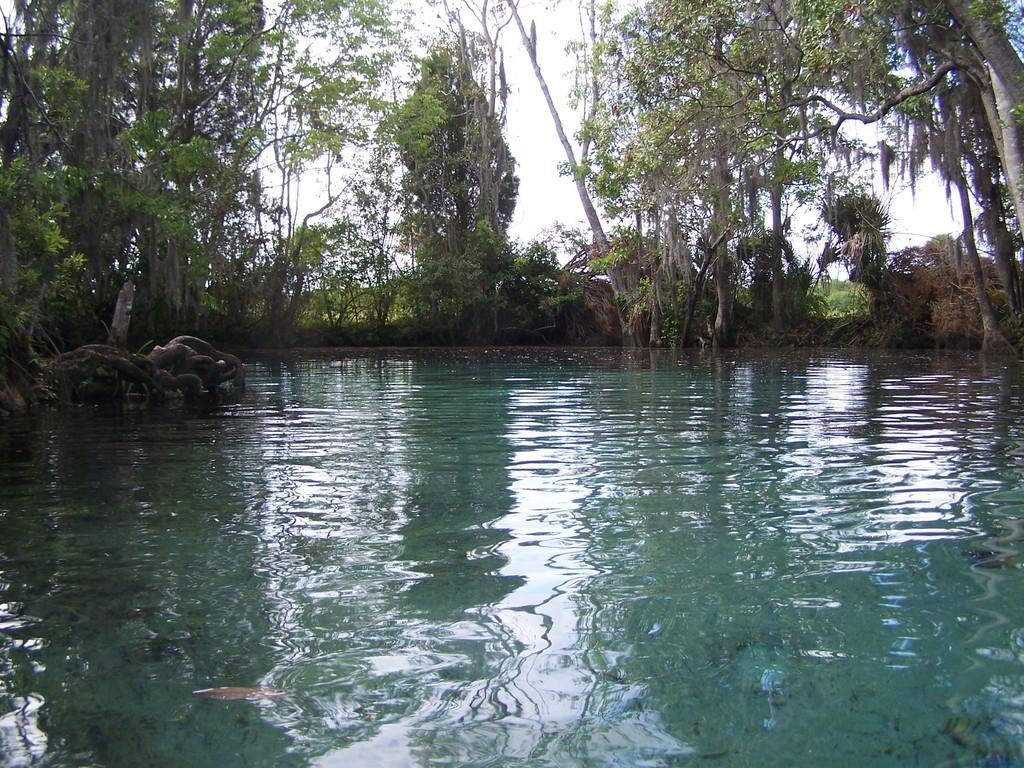How would you summarize this image in a sentence or two? In this picture we can see water and trees. In the background of the image we can see the sky. 